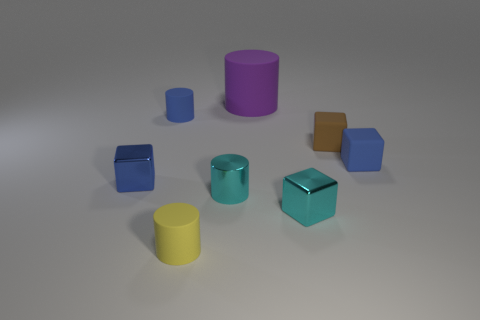Subtract all small cyan cylinders. How many cylinders are left? 3 Add 1 blue blocks. How many objects exist? 9 Subtract all green cylinders. How many blue cubes are left? 2 Subtract all purple cylinders. How many cylinders are left? 3 Subtract 2 cylinders. How many cylinders are left? 2 Subtract all cyan cylinders. Subtract all brown spheres. How many cylinders are left? 3 Subtract 0 green balls. How many objects are left? 8 Subtract all cyan spheres. Subtract all large purple rubber things. How many objects are left? 7 Add 2 small matte objects. How many small matte objects are left? 6 Add 7 shiny cylinders. How many shiny cylinders exist? 8 